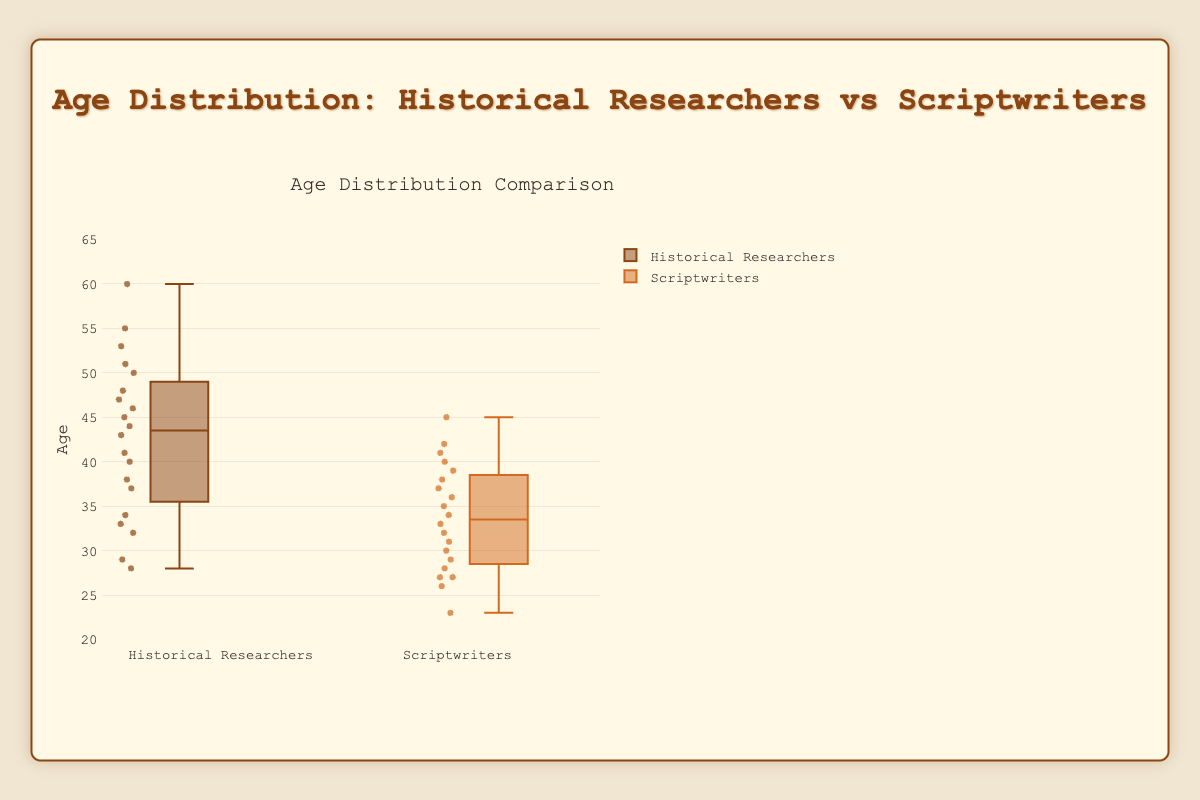What's the title of the figure? The title of the figure is located at the top center of the chart and reads "Age Distribution: Historical Researchers vs Scriptwriters."
Answer: Age Distribution: Historical Researchers vs Scriptwriters What does the y-axis represent? The y-axis represents the range of ages. It is labeled "Age" and ranges from about 20 to 65.
Answer: Age How many unique data points are there in the historical researchers group? Each boxplot shows individual data points; by counting the points shown for historical researchers, there are 20 unique data points.
Answer: 20 Which group has the higher median age? In a box plot, the median age is depicted by the horizontal line inside each box. By comparing, the median for historical researchers is higher than for scriptwriters.
Answer: Historical Researchers What's the interquartile range (IQR) of the scriptwriters' age distribution? The IQR is the difference between the third quartile (Q3) and the first quartile (Q1). By estimating from the box plot, Q3 for scriptwriters is around 40, and Q1 is around 29, so the IQR is 40 - 29 = 11.
Answer: 11 Which group has a greater age range? The range is the difference between the maximum and minimum values. For historical researchers, it ranges from about 28 to 60, while for scriptwriters, it ranges from about 23 to 45. Thus, historical researchers have a greater age range of 60 - 28 = 32, compared to scriptwriters' range of 45 - 23 = 22.
Answer: Historical Researchers What is the maximum age for scriptwriters? The maximum age for scriptwriters is depicted by the highest point above the box plot, which is 45.
Answer: 45 Is there any outlier in the scriptwriters' age distribution? Outliers are points that fall outside the whiskers of the box plot. The scriptwriters' box plot does not show any points outside the whiskers, indicating no outliers.
Answer: No Which group's age distribution has a higher variability? Variability can be inferred from the height of the box and the length of the whiskers. The historical researchers' distribution has a larger box and longer whiskers, indicating higher variability.
Answer: Historical Researchers 